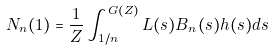<formula> <loc_0><loc_0><loc_500><loc_500>N _ { n } ( 1 ) = \frac { 1 } { Z } \int _ { 1 / n } ^ { G ( Z ) } L ( s ) B _ { n } ( s ) h ( s ) d s</formula> 